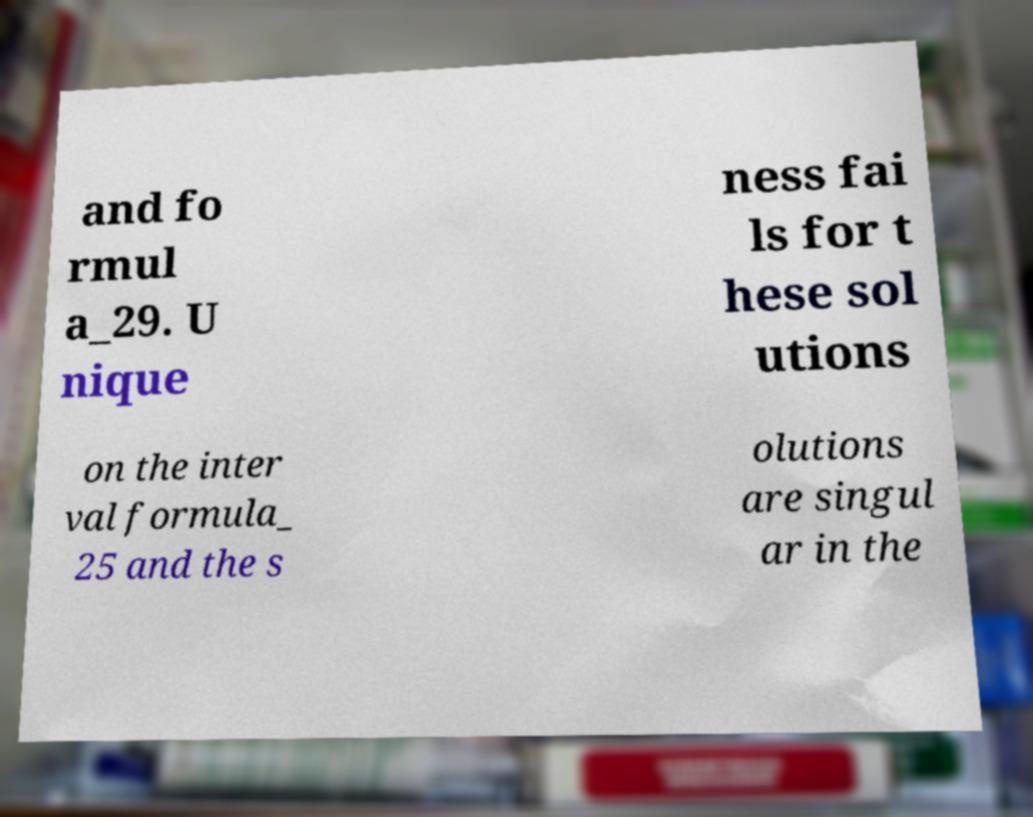Could you assist in decoding the text presented in this image and type it out clearly? and fo rmul a_29. U nique ness fai ls for t hese sol utions on the inter val formula_ 25 and the s olutions are singul ar in the 